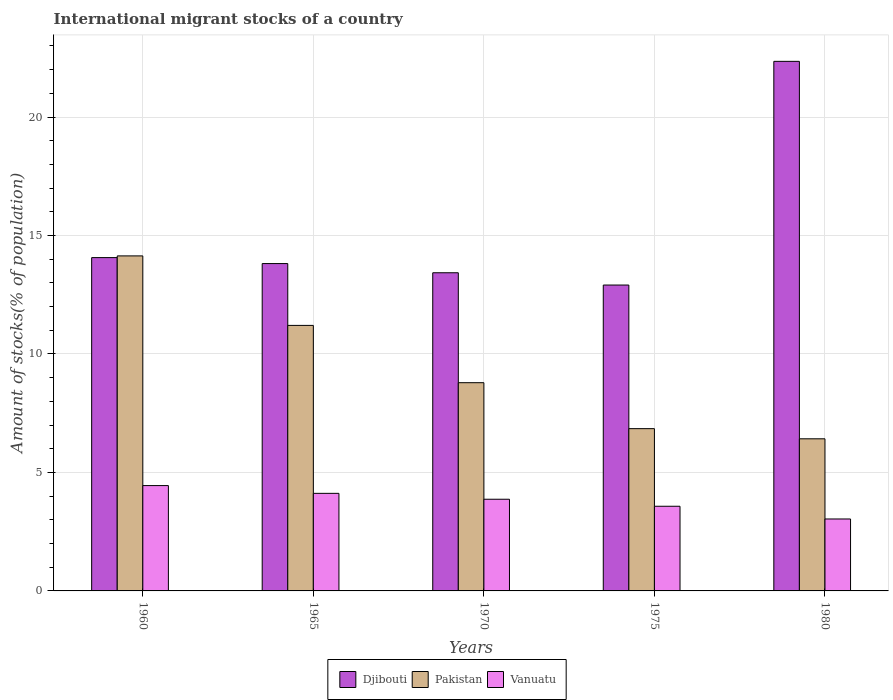How many groups of bars are there?
Provide a succinct answer. 5. Are the number of bars per tick equal to the number of legend labels?
Your answer should be compact. Yes. Are the number of bars on each tick of the X-axis equal?
Your answer should be compact. Yes. In how many cases, is the number of bars for a given year not equal to the number of legend labels?
Offer a very short reply. 0. What is the amount of stocks in in Djibouti in 1965?
Give a very brief answer. 13.82. Across all years, what is the maximum amount of stocks in in Vanuatu?
Offer a terse response. 4.45. Across all years, what is the minimum amount of stocks in in Pakistan?
Make the answer very short. 6.42. What is the total amount of stocks in in Pakistan in the graph?
Provide a succinct answer. 47.4. What is the difference between the amount of stocks in in Vanuatu in 1965 and that in 1970?
Your answer should be compact. 0.25. What is the difference between the amount of stocks in in Pakistan in 1975 and the amount of stocks in in Djibouti in 1980?
Your answer should be compact. -15.5. What is the average amount of stocks in in Djibouti per year?
Give a very brief answer. 15.31. In the year 1980, what is the difference between the amount of stocks in in Vanuatu and amount of stocks in in Pakistan?
Give a very brief answer. -3.38. What is the ratio of the amount of stocks in in Djibouti in 1960 to that in 1975?
Your response must be concise. 1.09. Is the difference between the amount of stocks in in Vanuatu in 1960 and 1980 greater than the difference between the amount of stocks in in Pakistan in 1960 and 1980?
Keep it short and to the point. No. What is the difference between the highest and the second highest amount of stocks in in Vanuatu?
Make the answer very short. 0.33. What is the difference between the highest and the lowest amount of stocks in in Djibouti?
Your answer should be compact. 9.44. What does the 3rd bar from the left in 1960 represents?
Your answer should be compact. Vanuatu. What does the 3rd bar from the right in 1960 represents?
Offer a very short reply. Djibouti. Is it the case that in every year, the sum of the amount of stocks in in Pakistan and amount of stocks in in Djibouti is greater than the amount of stocks in in Vanuatu?
Offer a very short reply. Yes. Are all the bars in the graph horizontal?
Your answer should be very brief. No. What is the difference between two consecutive major ticks on the Y-axis?
Offer a terse response. 5. Are the values on the major ticks of Y-axis written in scientific E-notation?
Provide a short and direct response. No. Does the graph contain grids?
Make the answer very short. Yes. How many legend labels are there?
Your answer should be compact. 3. What is the title of the graph?
Keep it short and to the point. International migrant stocks of a country. What is the label or title of the X-axis?
Your answer should be compact. Years. What is the label or title of the Y-axis?
Your answer should be compact. Amount of stocks(% of population). What is the Amount of stocks(% of population) in Djibouti in 1960?
Keep it short and to the point. 14.07. What is the Amount of stocks(% of population) of Pakistan in 1960?
Provide a short and direct response. 14.14. What is the Amount of stocks(% of population) in Vanuatu in 1960?
Ensure brevity in your answer.  4.45. What is the Amount of stocks(% of population) in Djibouti in 1965?
Your answer should be very brief. 13.82. What is the Amount of stocks(% of population) in Pakistan in 1965?
Your response must be concise. 11.21. What is the Amount of stocks(% of population) of Vanuatu in 1965?
Make the answer very short. 4.12. What is the Amount of stocks(% of population) in Djibouti in 1970?
Your response must be concise. 13.43. What is the Amount of stocks(% of population) of Pakistan in 1970?
Your response must be concise. 8.79. What is the Amount of stocks(% of population) in Vanuatu in 1970?
Provide a short and direct response. 3.87. What is the Amount of stocks(% of population) in Djibouti in 1975?
Give a very brief answer. 12.91. What is the Amount of stocks(% of population) in Pakistan in 1975?
Provide a short and direct response. 6.85. What is the Amount of stocks(% of population) of Vanuatu in 1975?
Provide a succinct answer. 3.57. What is the Amount of stocks(% of population) of Djibouti in 1980?
Your response must be concise. 22.35. What is the Amount of stocks(% of population) of Pakistan in 1980?
Your answer should be very brief. 6.42. What is the Amount of stocks(% of population) of Vanuatu in 1980?
Offer a terse response. 3.04. Across all years, what is the maximum Amount of stocks(% of population) in Djibouti?
Make the answer very short. 22.35. Across all years, what is the maximum Amount of stocks(% of population) of Pakistan?
Make the answer very short. 14.14. Across all years, what is the maximum Amount of stocks(% of population) in Vanuatu?
Your answer should be very brief. 4.45. Across all years, what is the minimum Amount of stocks(% of population) in Djibouti?
Provide a short and direct response. 12.91. Across all years, what is the minimum Amount of stocks(% of population) in Pakistan?
Ensure brevity in your answer.  6.42. Across all years, what is the minimum Amount of stocks(% of population) of Vanuatu?
Ensure brevity in your answer.  3.04. What is the total Amount of stocks(% of population) of Djibouti in the graph?
Keep it short and to the point. 76.57. What is the total Amount of stocks(% of population) of Pakistan in the graph?
Keep it short and to the point. 47.4. What is the total Amount of stocks(% of population) in Vanuatu in the graph?
Offer a very short reply. 19.04. What is the difference between the Amount of stocks(% of population) of Djibouti in 1960 and that in 1965?
Offer a very short reply. 0.25. What is the difference between the Amount of stocks(% of population) in Pakistan in 1960 and that in 1965?
Offer a terse response. 2.93. What is the difference between the Amount of stocks(% of population) of Vanuatu in 1960 and that in 1965?
Your answer should be compact. 0.33. What is the difference between the Amount of stocks(% of population) of Djibouti in 1960 and that in 1970?
Keep it short and to the point. 0.64. What is the difference between the Amount of stocks(% of population) in Pakistan in 1960 and that in 1970?
Offer a very short reply. 5.35. What is the difference between the Amount of stocks(% of population) of Vanuatu in 1960 and that in 1970?
Provide a succinct answer. 0.58. What is the difference between the Amount of stocks(% of population) in Djibouti in 1960 and that in 1975?
Your answer should be very brief. 1.16. What is the difference between the Amount of stocks(% of population) of Pakistan in 1960 and that in 1975?
Offer a very short reply. 7.29. What is the difference between the Amount of stocks(% of population) in Vanuatu in 1960 and that in 1975?
Provide a succinct answer. 0.87. What is the difference between the Amount of stocks(% of population) in Djibouti in 1960 and that in 1980?
Offer a very short reply. -8.28. What is the difference between the Amount of stocks(% of population) of Pakistan in 1960 and that in 1980?
Your response must be concise. 7.72. What is the difference between the Amount of stocks(% of population) in Vanuatu in 1960 and that in 1980?
Provide a short and direct response. 1.41. What is the difference between the Amount of stocks(% of population) in Djibouti in 1965 and that in 1970?
Your answer should be very brief. 0.39. What is the difference between the Amount of stocks(% of population) of Pakistan in 1965 and that in 1970?
Your answer should be compact. 2.42. What is the difference between the Amount of stocks(% of population) of Vanuatu in 1965 and that in 1970?
Give a very brief answer. 0.25. What is the difference between the Amount of stocks(% of population) in Djibouti in 1965 and that in 1975?
Give a very brief answer. 0.91. What is the difference between the Amount of stocks(% of population) in Pakistan in 1965 and that in 1975?
Offer a very short reply. 4.36. What is the difference between the Amount of stocks(% of population) of Vanuatu in 1965 and that in 1975?
Give a very brief answer. 0.54. What is the difference between the Amount of stocks(% of population) in Djibouti in 1965 and that in 1980?
Keep it short and to the point. -8.53. What is the difference between the Amount of stocks(% of population) of Pakistan in 1965 and that in 1980?
Provide a short and direct response. 4.79. What is the difference between the Amount of stocks(% of population) of Vanuatu in 1965 and that in 1980?
Your answer should be compact. 1.08. What is the difference between the Amount of stocks(% of population) of Djibouti in 1970 and that in 1975?
Offer a terse response. 0.52. What is the difference between the Amount of stocks(% of population) in Pakistan in 1970 and that in 1975?
Your answer should be very brief. 1.94. What is the difference between the Amount of stocks(% of population) of Vanuatu in 1970 and that in 1975?
Your response must be concise. 0.3. What is the difference between the Amount of stocks(% of population) in Djibouti in 1970 and that in 1980?
Make the answer very short. -8.92. What is the difference between the Amount of stocks(% of population) of Pakistan in 1970 and that in 1980?
Give a very brief answer. 2.37. What is the difference between the Amount of stocks(% of population) of Vanuatu in 1970 and that in 1980?
Offer a very short reply. 0.83. What is the difference between the Amount of stocks(% of population) of Djibouti in 1975 and that in 1980?
Give a very brief answer. -9.44. What is the difference between the Amount of stocks(% of population) in Pakistan in 1975 and that in 1980?
Provide a succinct answer. 0.43. What is the difference between the Amount of stocks(% of population) of Vanuatu in 1975 and that in 1980?
Offer a very short reply. 0.54. What is the difference between the Amount of stocks(% of population) of Djibouti in 1960 and the Amount of stocks(% of population) of Pakistan in 1965?
Your answer should be compact. 2.86. What is the difference between the Amount of stocks(% of population) in Djibouti in 1960 and the Amount of stocks(% of population) in Vanuatu in 1965?
Ensure brevity in your answer.  9.95. What is the difference between the Amount of stocks(% of population) of Pakistan in 1960 and the Amount of stocks(% of population) of Vanuatu in 1965?
Your response must be concise. 10.02. What is the difference between the Amount of stocks(% of population) of Djibouti in 1960 and the Amount of stocks(% of population) of Pakistan in 1970?
Give a very brief answer. 5.28. What is the difference between the Amount of stocks(% of population) in Djibouti in 1960 and the Amount of stocks(% of population) in Vanuatu in 1970?
Offer a terse response. 10.2. What is the difference between the Amount of stocks(% of population) of Pakistan in 1960 and the Amount of stocks(% of population) of Vanuatu in 1970?
Your response must be concise. 10.27. What is the difference between the Amount of stocks(% of population) of Djibouti in 1960 and the Amount of stocks(% of population) of Pakistan in 1975?
Offer a very short reply. 7.22. What is the difference between the Amount of stocks(% of population) in Djibouti in 1960 and the Amount of stocks(% of population) in Vanuatu in 1975?
Your answer should be compact. 10.49. What is the difference between the Amount of stocks(% of population) of Pakistan in 1960 and the Amount of stocks(% of population) of Vanuatu in 1975?
Provide a succinct answer. 10.57. What is the difference between the Amount of stocks(% of population) of Djibouti in 1960 and the Amount of stocks(% of population) of Pakistan in 1980?
Give a very brief answer. 7.65. What is the difference between the Amount of stocks(% of population) in Djibouti in 1960 and the Amount of stocks(% of population) in Vanuatu in 1980?
Make the answer very short. 11.03. What is the difference between the Amount of stocks(% of population) in Pakistan in 1960 and the Amount of stocks(% of population) in Vanuatu in 1980?
Keep it short and to the point. 11.1. What is the difference between the Amount of stocks(% of population) in Djibouti in 1965 and the Amount of stocks(% of population) in Pakistan in 1970?
Offer a very short reply. 5.03. What is the difference between the Amount of stocks(% of population) of Djibouti in 1965 and the Amount of stocks(% of population) of Vanuatu in 1970?
Your answer should be very brief. 9.95. What is the difference between the Amount of stocks(% of population) in Pakistan in 1965 and the Amount of stocks(% of population) in Vanuatu in 1970?
Provide a succinct answer. 7.34. What is the difference between the Amount of stocks(% of population) in Djibouti in 1965 and the Amount of stocks(% of population) in Pakistan in 1975?
Keep it short and to the point. 6.97. What is the difference between the Amount of stocks(% of population) of Djibouti in 1965 and the Amount of stocks(% of population) of Vanuatu in 1975?
Keep it short and to the point. 10.24. What is the difference between the Amount of stocks(% of population) in Pakistan in 1965 and the Amount of stocks(% of population) in Vanuatu in 1975?
Give a very brief answer. 7.63. What is the difference between the Amount of stocks(% of population) in Djibouti in 1965 and the Amount of stocks(% of population) in Pakistan in 1980?
Make the answer very short. 7.4. What is the difference between the Amount of stocks(% of population) of Djibouti in 1965 and the Amount of stocks(% of population) of Vanuatu in 1980?
Offer a terse response. 10.78. What is the difference between the Amount of stocks(% of population) of Pakistan in 1965 and the Amount of stocks(% of population) of Vanuatu in 1980?
Your answer should be compact. 8.17. What is the difference between the Amount of stocks(% of population) of Djibouti in 1970 and the Amount of stocks(% of population) of Pakistan in 1975?
Provide a succinct answer. 6.58. What is the difference between the Amount of stocks(% of population) in Djibouti in 1970 and the Amount of stocks(% of population) in Vanuatu in 1975?
Keep it short and to the point. 9.85. What is the difference between the Amount of stocks(% of population) of Pakistan in 1970 and the Amount of stocks(% of population) of Vanuatu in 1975?
Your answer should be compact. 5.22. What is the difference between the Amount of stocks(% of population) of Djibouti in 1970 and the Amount of stocks(% of population) of Pakistan in 1980?
Your answer should be very brief. 7.01. What is the difference between the Amount of stocks(% of population) in Djibouti in 1970 and the Amount of stocks(% of population) in Vanuatu in 1980?
Give a very brief answer. 10.39. What is the difference between the Amount of stocks(% of population) of Pakistan in 1970 and the Amount of stocks(% of population) of Vanuatu in 1980?
Make the answer very short. 5.75. What is the difference between the Amount of stocks(% of population) of Djibouti in 1975 and the Amount of stocks(% of population) of Pakistan in 1980?
Ensure brevity in your answer.  6.49. What is the difference between the Amount of stocks(% of population) of Djibouti in 1975 and the Amount of stocks(% of population) of Vanuatu in 1980?
Offer a terse response. 9.87. What is the difference between the Amount of stocks(% of population) of Pakistan in 1975 and the Amount of stocks(% of population) of Vanuatu in 1980?
Offer a terse response. 3.81. What is the average Amount of stocks(% of population) of Djibouti per year?
Give a very brief answer. 15.31. What is the average Amount of stocks(% of population) of Pakistan per year?
Provide a succinct answer. 9.48. What is the average Amount of stocks(% of population) in Vanuatu per year?
Offer a very short reply. 3.81. In the year 1960, what is the difference between the Amount of stocks(% of population) in Djibouti and Amount of stocks(% of population) in Pakistan?
Your answer should be compact. -0.07. In the year 1960, what is the difference between the Amount of stocks(% of population) in Djibouti and Amount of stocks(% of population) in Vanuatu?
Offer a very short reply. 9.62. In the year 1960, what is the difference between the Amount of stocks(% of population) of Pakistan and Amount of stocks(% of population) of Vanuatu?
Your response must be concise. 9.69. In the year 1965, what is the difference between the Amount of stocks(% of population) of Djibouti and Amount of stocks(% of population) of Pakistan?
Offer a very short reply. 2.61. In the year 1965, what is the difference between the Amount of stocks(% of population) of Djibouti and Amount of stocks(% of population) of Vanuatu?
Give a very brief answer. 9.7. In the year 1965, what is the difference between the Amount of stocks(% of population) of Pakistan and Amount of stocks(% of population) of Vanuatu?
Your response must be concise. 7.09. In the year 1970, what is the difference between the Amount of stocks(% of population) in Djibouti and Amount of stocks(% of population) in Pakistan?
Offer a very short reply. 4.64. In the year 1970, what is the difference between the Amount of stocks(% of population) of Djibouti and Amount of stocks(% of population) of Vanuatu?
Give a very brief answer. 9.56. In the year 1970, what is the difference between the Amount of stocks(% of population) of Pakistan and Amount of stocks(% of population) of Vanuatu?
Provide a short and direct response. 4.92. In the year 1975, what is the difference between the Amount of stocks(% of population) in Djibouti and Amount of stocks(% of population) in Pakistan?
Make the answer very short. 6.06. In the year 1975, what is the difference between the Amount of stocks(% of population) in Djibouti and Amount of stocks(% of population) in Vanuatu?
Keep it short and to the point. 9.34. In the year 1975, what is the difference between the Amount of stocks(% of population) of Pakistan and Amount of stocks(% of population) of Vanuatu?
Ensure brevity in your answer.  3.28. In the year 1980, what is the difference between the Amount of stocks(% of population) in Djibouti and Amount of stocks(% of population) in Pakistan?
Your answer should be compact. 15.93. In the year 1980, what is the difference between the Amount of stocks(% of population) of Djibouti and Amount of stocks(% of population) of Vanuatu?
Give a very brief answer. 19.31. In the year 1980, what is the difference between the Amount of stocks(% of population) in Pakistan and Amount of stocks(% of population) in Vanuatu?
Your answer should be very brief. 3.38. What is the ratio of the Amount of stocks(% of population) in Djibouti in 1960 to that in 1965?
Ensure brevity in your answer.  1.02. What is the ratio of the Amount of stocks(% of population) in Pakistan in 1960 to that in 1965?
Make the answer very short. 1.26. What is the ratio of the Amount of stocks(% of population) of Vanuatu in 1960 to that in 1965?
Your answer should be very brief. 1.08. What is the ratio of the Amount of stocks(% of population) of Djibouti in 1960 to that in 1970?
Provide a short and direct response. 1.05. What is the ratio of the Amount of stocks(% of population) of Pakistan in 1960 to that in 1970?
Ensure brevity in your answer.  1.61. What is the ratio of the Amount of stocks(% of population) in Vanuatu in 1960 to that in 1970?
Your answer should be compact. 1.15. What is the ratio of the Amount of stocks(% of population) in Djibouti in 1960 to that in 1975?
Keep it short and to the point. 1.09. What is the ratio of the Amount of stocks(% of population) in Pakistan in 1960 to that in 1975?
Provide a short and direct response. 2.06. What is the ratio of the Amount of stocks(% of population) of Vanuatu in 1960 to that in 1975?
Your answer should be very brief. 1.24. What is the ratio of the Amount of stocks(% of population) of Djibouti in 1960 to that in 1980?
Your answer should be compact. 0.63. What is the ratio of the Amount of stocks(% of population) of Pakistan in 1960 to that in 1980?
Your answer should be very brief. 2.2. What is the ratio of the Amount of stocks(% of population) in Vanuatu in 1960 to that in 1980?
Offer a very short reply. 1.46. What is the ratio of the Amount of stocks(% of population) in Djibouti in 1965 to that in 1970?
Your response must be concise. 1.03. What is the ratio of the Amount of stocks(% of population) of Pakistan in 1965 to that in 1970?
Make the answer very short. 1.28. What is the ratio of the Amount of stocks(% of population) of Vanuatu in 1965 to that in 1970?
Give a very brief answer. 1.06. What is the ratio of the Amount of stocks(% of population) of Djibouti in 1965 to that in 1975?
Offer a terse response. 1.07. What is the ratio of the Amount of stocks(% of population) of Pakistan in 1965 to that in 1975?
Offer a very short reply. 1.64. What is the ratio of the Amount of stocks(% of population) of Vanuatu in 1965 to that in 1975?
Provide a succinct answer. 1.15. What is the ratio of the Amount of stocks(% of population) in Djibouti in 1965 to that in 1980?
Give a very brief answer. 0.62. What is the ratio of the Amount of stocks(% of population) of Pakistan in 1965 to that in 1980?
Ensure brevity in your answer.  1.75. What is the ratio of the Amount of stocks(% of population) of Vanuatu in 1965 to that in 1980?
Your answer should be very brief. 1.36. What is the ratio of the Amount of stocks(% of population) of Djibouti in 1970 to that in 1975?
Make the answer very short. 1.04. What is the ratio of the Amount of stocks(% of population) of Pakistan in 1970 to that in 1975?
Provide a succinct answer. 1.28. What is the ratio of the Amount of stocks(% of population) in Vanuatu in 1970 to that in 1975?
Offer a terse response. 1.08. What is the ratio of the Amount of stocks(% of population) of Djibouti in 1970 to that in 1980?
Keep it short and to the point. 0.6. What is the ratio of the Amount of stocks(% of population) of Pakistan in 1970 to that in 1980?
Ensure brevity in your answer.  1.37. What is the ratio of the Amount of stocks(% of population) in Vanuatu in 1970 to that in 1980?
Your answer should be very brief. 1.27. What is the ratio of the Amount of stocks(% of population) in Djibouti in 1975 to that in 1980?
Your answer should be compact. 0.58. What is the ratio of the Amount of stocks(% of population) of Pakistan in 1975 to that in 1980?
Keep it short and to the point. 1.07. What is the ratio of the Amount of stocks(% of population) in Vanuatu in 1975 to that in 1980?
Ensure brevity in your answer.  1.18. What is the difference between the highest and the second highest Amount of stocks(% of population) of Djibouti?
Offer a terse response. 8.28. What is the difference between the highest and the second highest Amount of stocks(% of population) in Pakistan?
Your response must be concise. 2.93. What is the difference between the highest and the second highest Amount of stocks(% of population) of Vanuatu?
Offer a terse response. 0.33. What is the difference between the highest and the lowest Amount of stocks(% of population) of Djibouti?
Offer a terse response. 9.44. What is the difference between the highest and the lowest Amount of stocks(% of population) in Pakistan?
Make the answer very short. 7.72. What is the difference between the highest and the lowest Amount of stocks(% of population) of Vanuatu?
Offer a terse response. 1.41. 